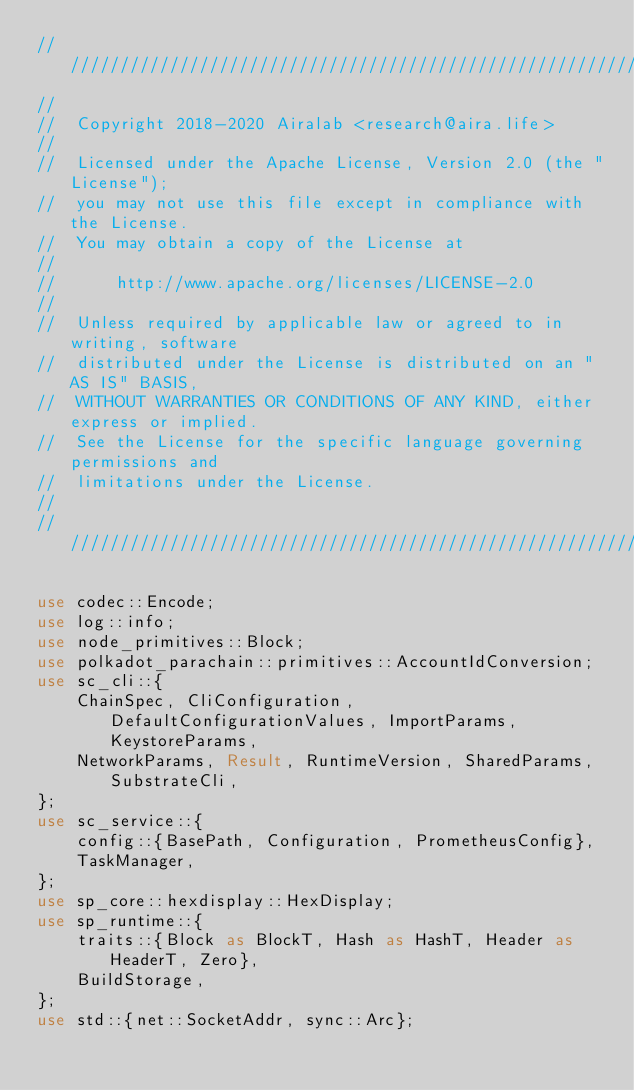Convert code to text. <code><loc_0><loc_0><loc_500><loc_500><_Rust_>///////////////////////////////////////////////////////////////////////////////
//
//  Copyright 2018-2020 Airalab <research@aira.life>
//
//  Licensed under the Apache License, Version 2.0 (the "License");
//  you may not use this file except in compliance with the License.
//  You may obtain a copy of the License at
//
//      http://www.apache.org/licenses/LICENSE-2.0
//
//  Unless required by applicable law or agreed to in writing, software
//  distributed under the License is distributed on an "AS IS" BASIS,
//  WITHOUT WARRANTIES OR CONDITIONS OF ANY KIND, either express or implied.
//  See the License for the specific language governing permissions and
//  limitations under the License.
//
///////////////////////////////////////////////////////////////////////////////

use codec::Encode;
use log::info;
use node_primitives::Block;
use polkadot_parachain::primitives::AccountIdConversion;
use sc_cli::{
    ChainSpec, CliConfiguration, DefaultConfigurationValues, ImportParams, KeystoreParams,
    NetworkParams, Result, RuntimeVersion, SharedParams, SubstrateCli,
};
use sc_service::{
    config::{BasePath, Configuration, PrometheusConfig},
    TaskManager,
};
use sp_core::hexdisplay::HexDisplay;
use sp_runtime::{
    traits::{Block as BlockT, Hash as HashT, Header as HeaderT, Zero},
    BuildStorage,
};
use std::{net::SocketAddr, sync::Arc};
</code> 